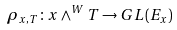Convert formula to latex. <formula><loc_0><loc_0><loc_500><loc_500>\rho _ { x , T } \colon x \wedge ^ { W } T \to G L ( E _ { x } )</formula> 